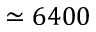Convert formula to latex. <formula><loc_0><loc_0><loc_500><loc_500>\simeq 6 4 0 0</formula> 